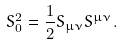Convert formula to latex. <formula><loc_0><loc_0><loc_500><loc_500>S _ { 0 } ^ { 2 } = \frac { 1 } { 2 } S _ { \mu \nu } S ^ { \mu \nu } .</formula> 